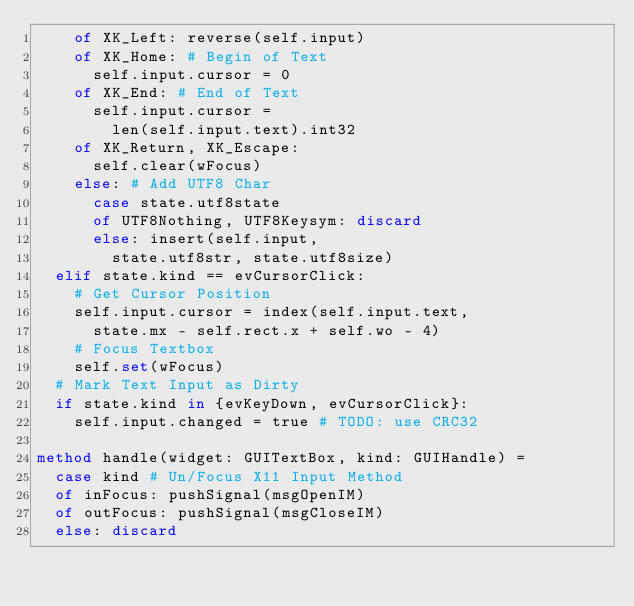<code> <loc_0><loc_0><loc_500><loc_500><_Nim_>    of XK_Left: reverse(self.input)
    of XK_Home: # Begin of Text
      self.input.cursor = 0
    of XK_End: # End of Text
      self.input.cursor =
        len(self.input.text).int32
    of XK_Return, XK_Escape: 
      self.clear(wFocus)
    else: # Add UTF8 Char
      case state.utf8state
      of UTF8Nothing, UTF8Keysym: discard
      else: insert(self.input, 
        state.utf8str, state.utf8size)
  elif state.kind == evCursorClick:
    # Get Cursor Position
    self.input.cursor = index(self.input.text,
      state.mx - self.rect.x + self.wo - 4)
    # Focus Textbox
    self.set(wFocus)
  # Mark Text Input as Dirty
  if state.kind in {evKeyDown, evCursorClick}:
    self.input.changed = true # TODO: use CRC32

method handle(widget: GUITextBox, kind: GUIHandle) =
  case kind # Un/Focus X11 Input Method
  of inFocus: pushSignal(msgOpenIM)
  of outFocus: pushSignal(msgCloseIM)
  else: discard
</code> 